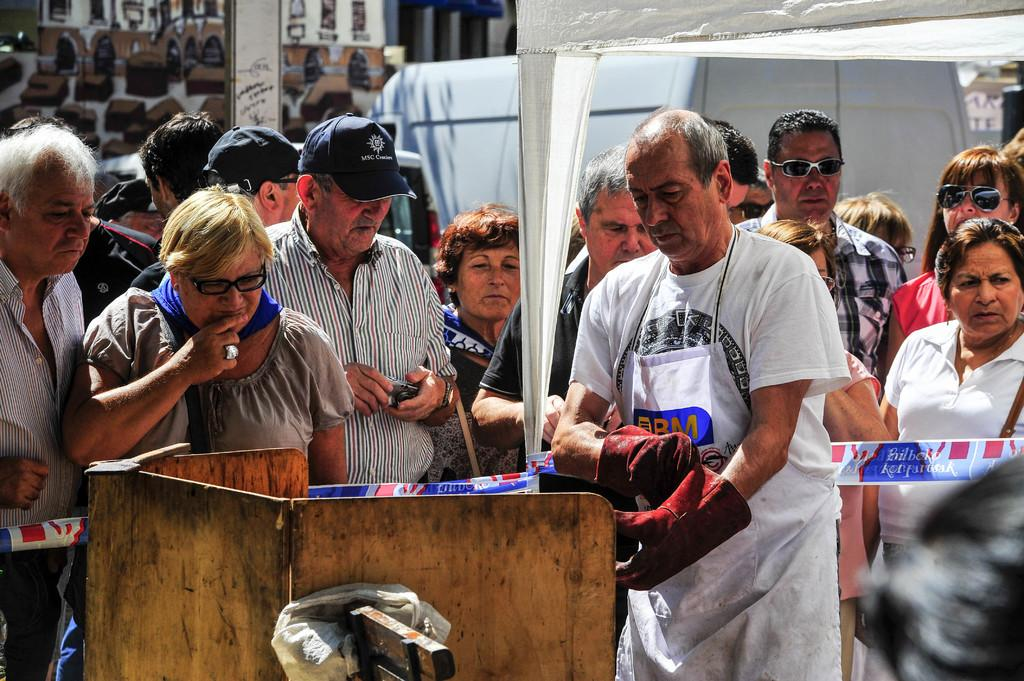What is happening in the middle of the image? There are persons standing in the middle of the image. What can be seen in the background of the image? There is a building in the background of the image. Can you describe the object located at the bottom of the image? Unfortunately, the provided facts do not give any information about the object at the bottom of the image. Can you see a plane flying in the image? There is no mention of a plane in the provided facts, so it cannot be determined if a plane is present in the image. What is the expression on the face of the person in the image? The provided facts do not mention any person's face, so it cannot be determined if a face is present in the image. 